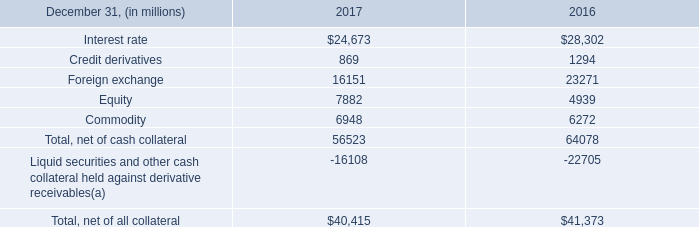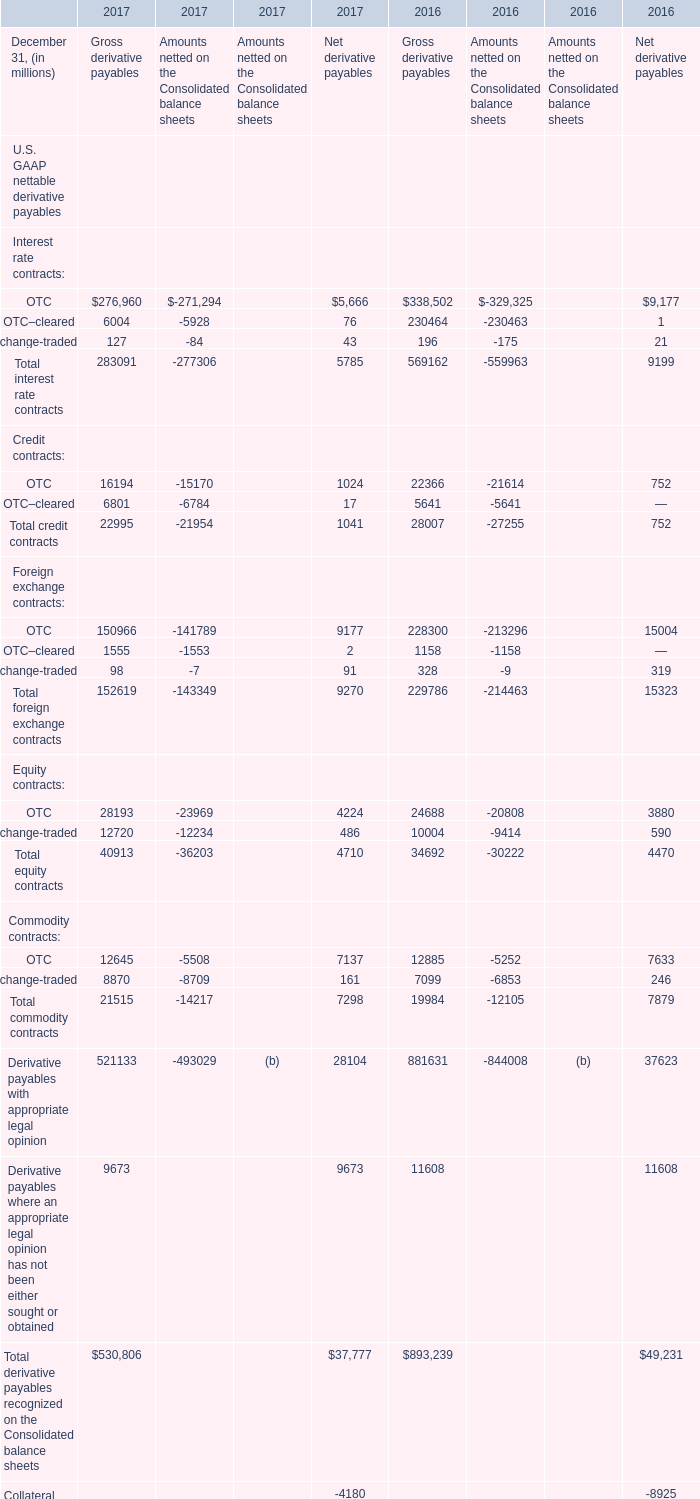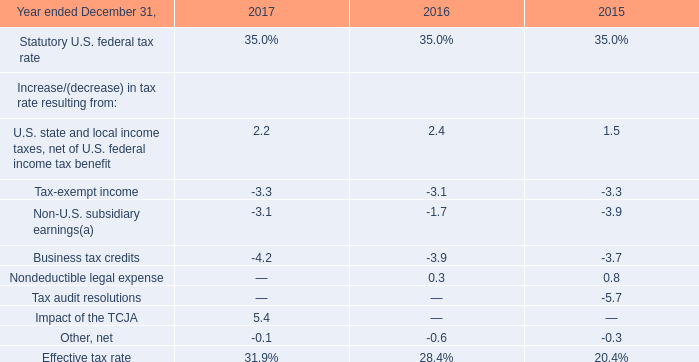credit derivatives for 2017 were what percent of the foreign exchange derivatives? 
Computations: (869 / 16151)
Answer: 0.0538. 